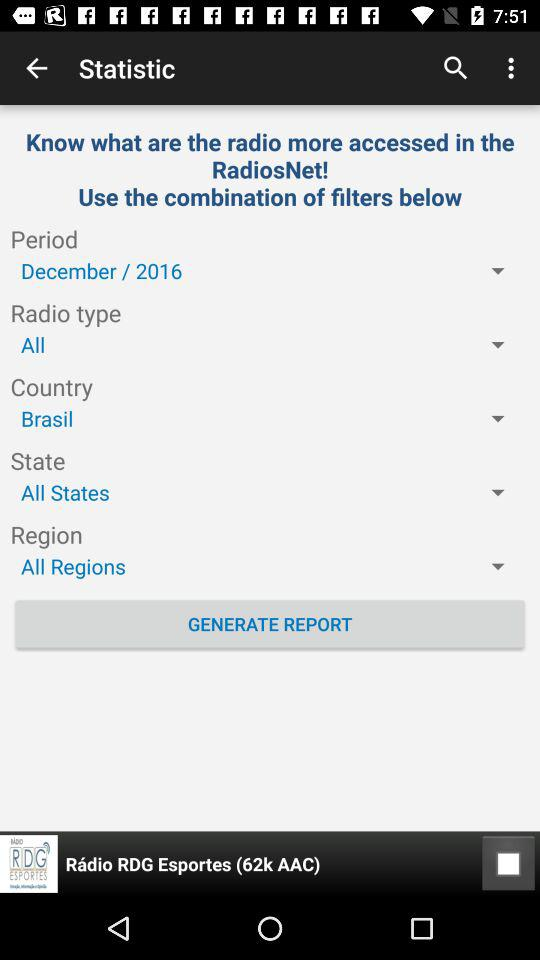What is the selected region? The selected region is "All Regions". 